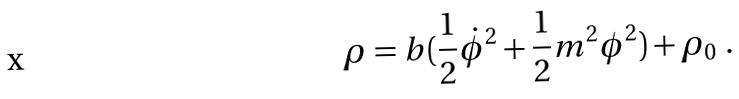<formula> <loc_0><loc_0><loc_500><loc_500>\rho & = b ( \frac { 1 } { 2 } \dot { \phi } ^ { 2 } + \frac { 1 } { 2 } m ^ { 2 } \phi ^ { 2 } ) + \rho _ { 0 } \ .</formula> 